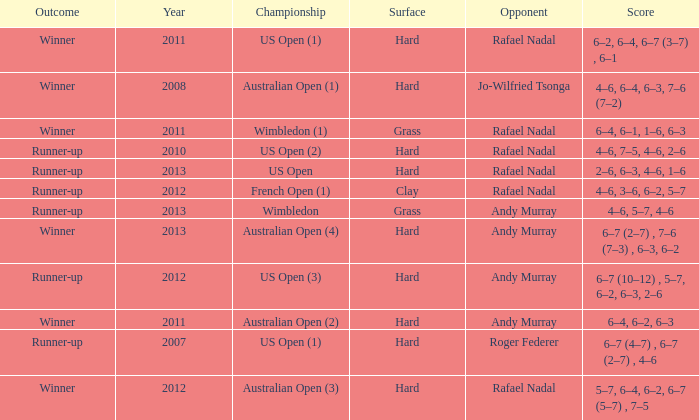I'm looking to parse the entire table for insights. Could you assist me with that? {'header': ['Outcome', 'Year', 'Championship', 'Surface', 'Opponent', 'Score'], 'rows': [['Winner', '2011', 'US Open (1)', 'Hard', 'Rafael Nadal', '6–2, 6–4, 6–7 (3–7) , 6–1'], ['Winner', '2008', 'Australian Open (1)', 'Hard', 'Jo-Wilfried Tsonga', '4–6, 6–4, 6–3, 7–6 (7–2)'], ['Winner', '2011', 'Wimbledon (1)', 'Grass', 'Rafael Nadal', '6–4, 6–1, 1–6, 6–3'], ['Runner-up', '2010', 'US Open (2)', 'Hard', 'Rafael Nadal', '4–6, 7–5, 4–6, 2–6'], ['Runner-up', '2013', 'US Open', 'Hard', 'Rafael Nadal', '2–6, 6–3, 4–6, 1–6'], ['Runner-up', '2012', 'French Open (1)', 'Clay', 'Rafael Nadal', '4–6, 3–6, 6–2, 5–7'], ['Runner-up', '2013', 'Wimbledon', 'Grass', 'Andy Murray', '4–6, 5–7, 4–6'], ['Winner', '2013', 'Australian Open (4)', 'Hard', 'Andy Murray', '6–7 (2–7) , 7–6 (7–3) , 6–3, 6–2'], ['Runner-up', '2012', 'US Open (3)', 'Hard', 'Andy Murray', '6–7 (10–12) , 5–7, 6–2, 6–3, 2–6'], ['Winner', '2011', 'Australian Open (2)', 'Hard', 'Andy Murray', '6–4, 6–2, 6–3'], ['Runner-up', '2007', 'US Open (1)', 'Hard', 'Roger Federer', '6–7 (4–7) , 6–7 (2–7) , 4–6'], ['Winner', '2012', 'Australian Open (3)', 'Hard', 'Rafael Nadal', '5–7, 6–4, 6–2, 6–7 (5–7) , 7–5']]} What is the outcome of the match with Roger Federer as the opponent? Runner-up. 